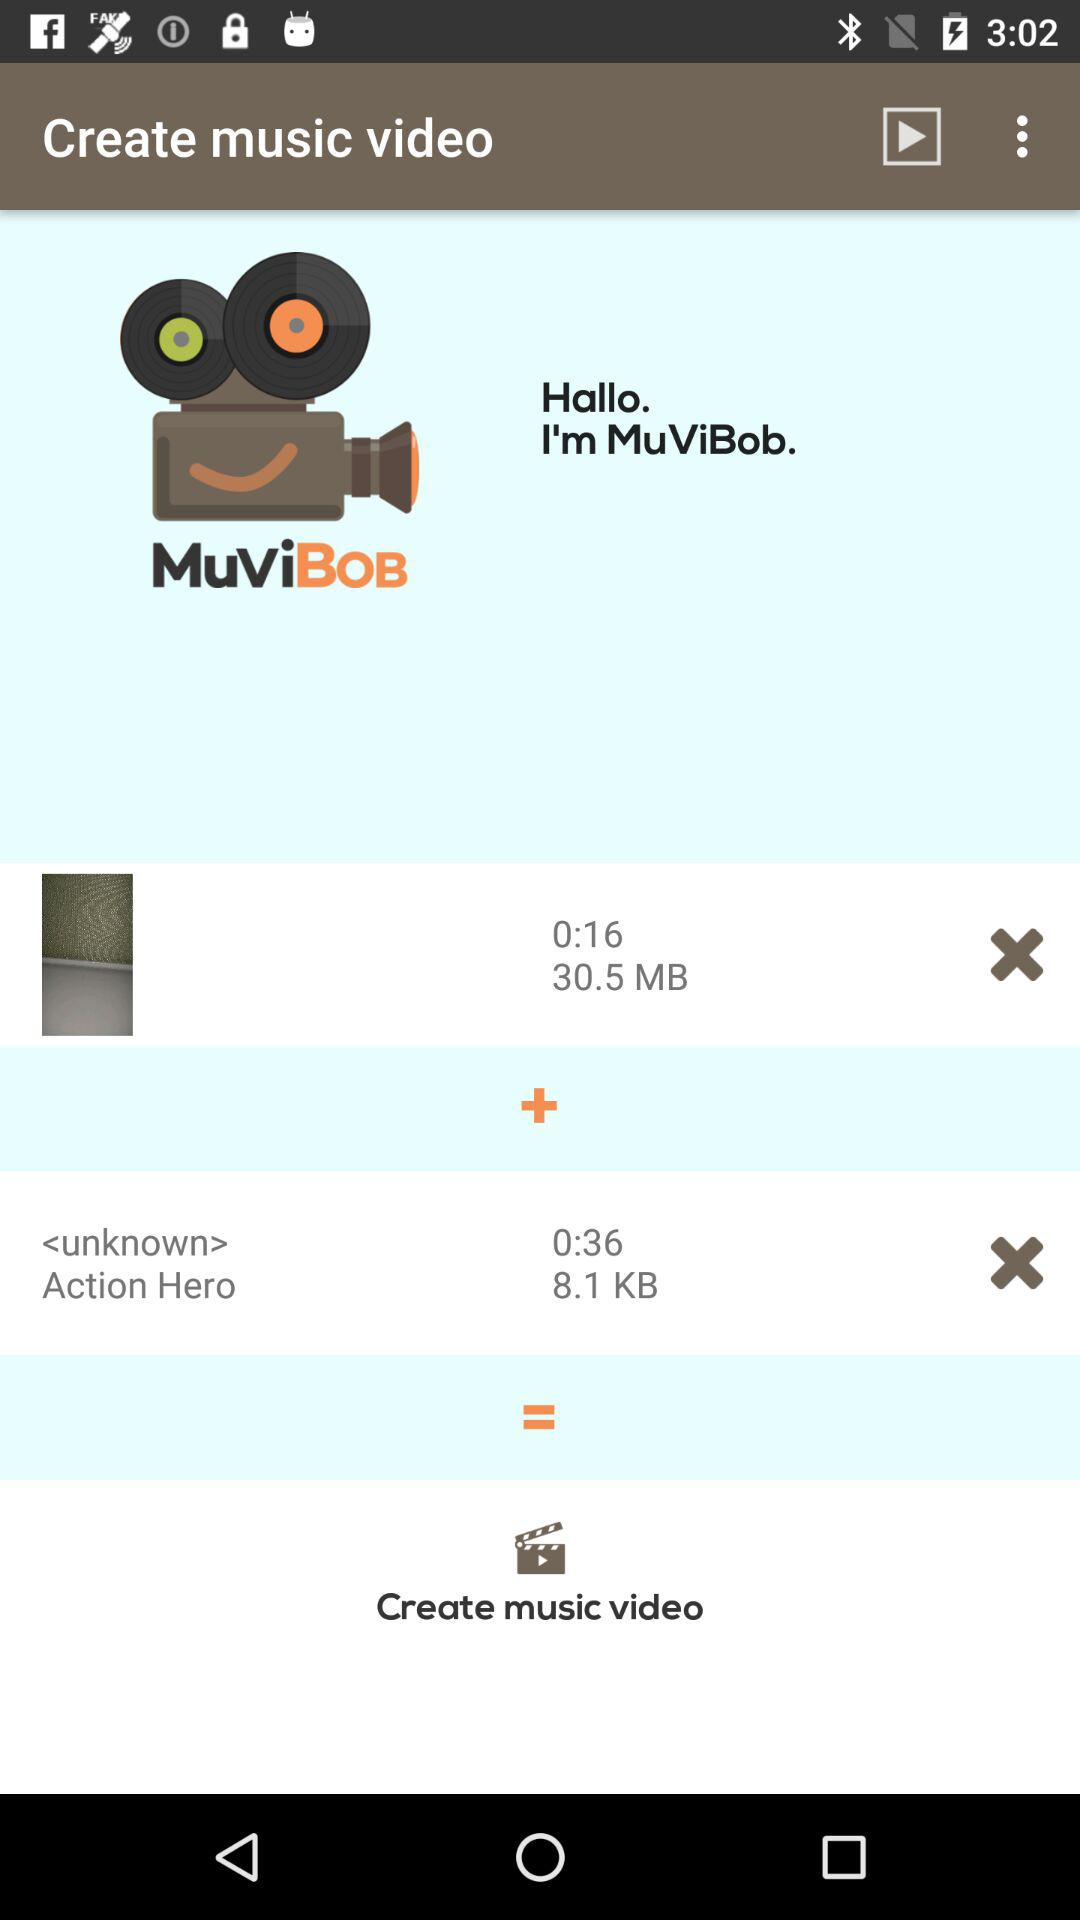How many MB does the 16-second video occupy? The video occupies 30.5 MB. 